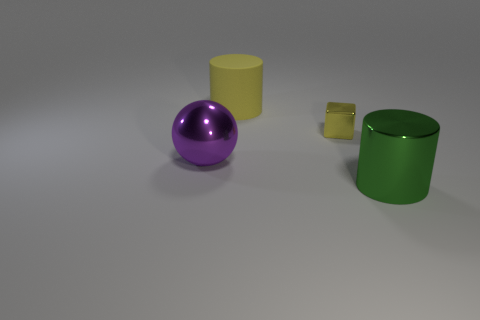There is a green shiny cylinder; is its size the same as the object that is to the left of the matte thing?
Your answer should be very brief. Yes. Are there fewer spheres behind the tiny yellow metallic cube than large things on the left side of the ball?
Provide a short and direct response. No. What size is the cylinder on the left side of the metal cylinder?
Your answer should be very brief. Large. Is the size of the cube the same as the rubber thing?
Make the answer very short. No. What number of large metallic objects are both to the left of the big rubber cylinder and in front of the big purple metallic object?
Give a very brief answer. 0. How many green things are big objects or rubber objects?
Provide a short and direct response. 1. How many shiny objects are either purple objects or large yellow cylinders?
Your answer should be compact. 1. Is there a cylinder?
Give a very brief answer. Yes. Does the small yellow shiny thing have the same shape as the big yellow rubber object?
Offer a very short reply. No. How many metallic cylinders are behind the big shiny object behind the big shiny object in front of the purple object?
Your answer should be very brief. 0. 